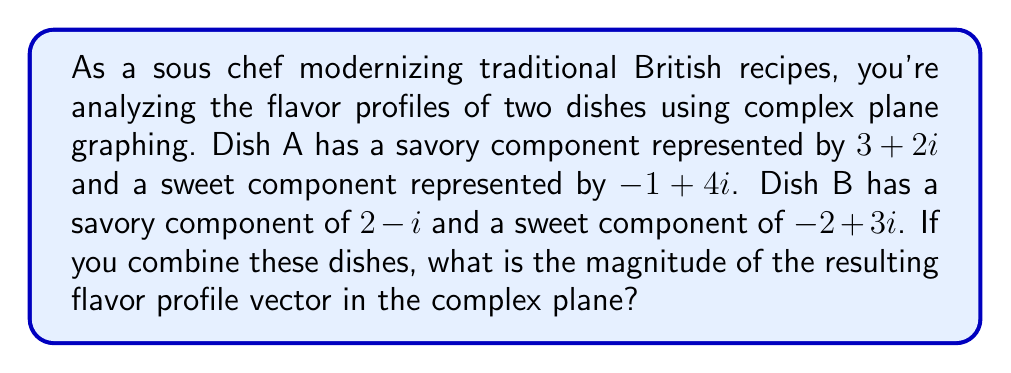Give your solution to this math problem. Let's approach this step-by-step:

1) First, we need to add the components of both dishes:
   Dish A: $(3+2i) + (-1+4i) = 2+6i$
   Dish B: $(2-i) + (-2+3i) = 2i$

2) Now, we combine the two dishes by adding their total flavor profiles:
   $(2+6i) + (2i) = 2+8i$

3) This gives us the resulting flavor profile vector in the complex plane.

4) To find the magnitude of this vector, we use the formula:
   $|a+bi| = \sqrt{a^2 + b^2}$

5) In this case, $a=2$ and $b=8$:
   $|2+8i| = \sqrt{2^2 + 8^2}$

6) Simplify:
   $|2+8i| = \sqrt{4 + 64} = \sqrt{68}$

7) Simplify further:
   $\sqrt{68} = 2\sqrt{17}$

Therefore, the magnitude of the resulting flavor profile vector is $2\sqrt{17}$.
Answer: $2\sqrt{17}$ 